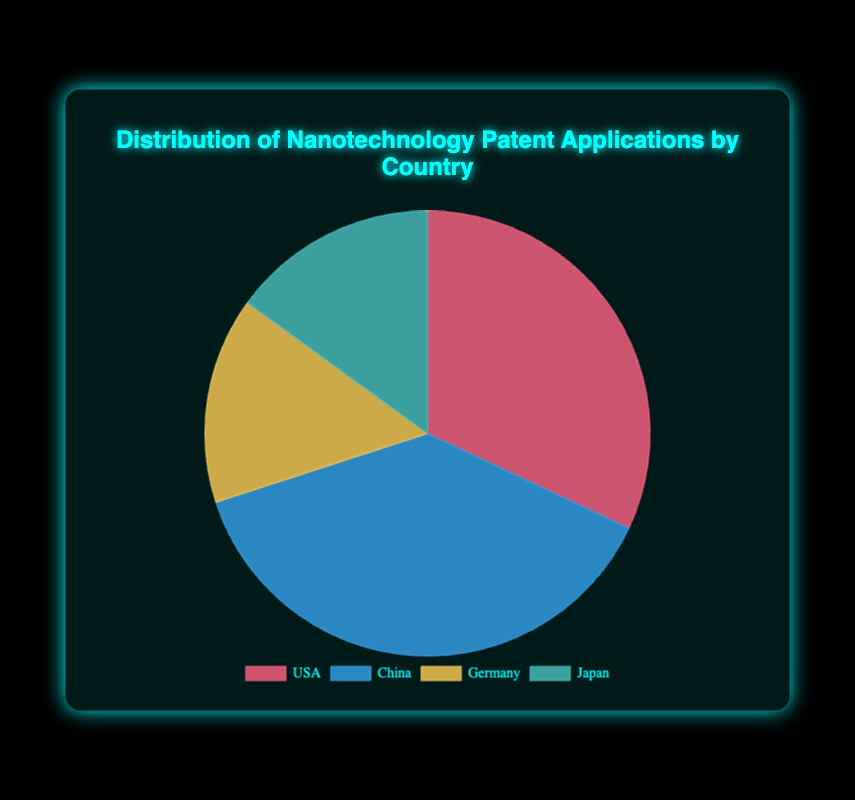What percentage of nanotechnology patent applications does China have compared to the USA? China has 38% and the USA has 32%. To compare, we calculate \(\frac{38}{32} \approx 1.1875\), indicating China has approximately 18.75% more applications than the USA.
Answer: 18.75% Which two countries have the same percentage of nanotechnology patent applications? The chart shows Germany and Japan each having 15%.
Answer: Germany and Japan What is the total percentage of nanotechnology patent applications for Germany and Japan combined? Germany has 15% and Japan has 15%. Adding these gives 15 + 15 = 30%.
Answer: 30% Which country has the highest number of nanotechnology patent applications? China has the highest percentage at 38%.
Answer: China If you sum the percentages of the USA and China, what is the value? The USA has 32% and China has 38%. Adding these gives 32 + 38 = 70%.
Answer: 70% How many percentage points ahead is China compared to Germany? China is at 38% and Germany is at 15%. The difference is 38 - 15 = 23 percentage points.
Answer: 23 Which segment on the pie chart is colored blue? In the pie chart, China is represented by the blue segment.
Answer: China What is the average percentage of patent applications among all four countries? Adding the percentages: 32 (USA) + 38 (China) + 15 (Germany) + 15 (Japan) = 100. Dividing by 4, the average is \( \frac{100}{4} = 25 \).
Answer: 25% Is the proportion of patent applications from Japan greater than half of China's? Half of China's percentage is \( \frac{38}{2} = 19 \). Japan has 15%, which is less than 19%.
Answer: No By how much does the patent percentage of the USA exceed that of Germany? The USA has 32% and Germany has 15%. The difference is 32 - 15 = 17 percentage points.
Answer: 17 